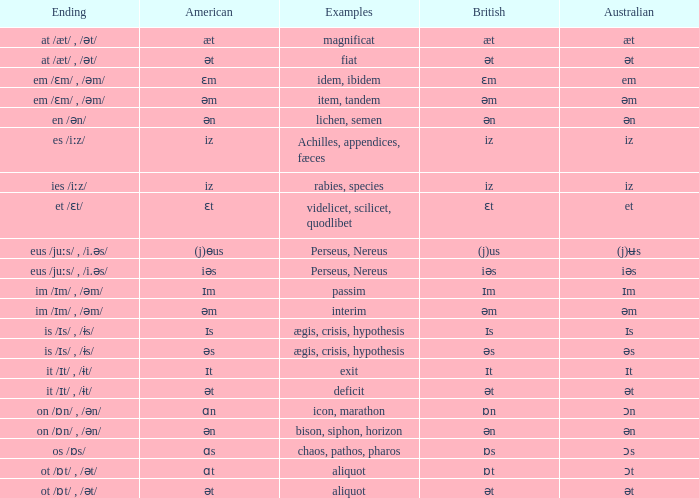Which Australian has British of ɒs? Ɔs. 